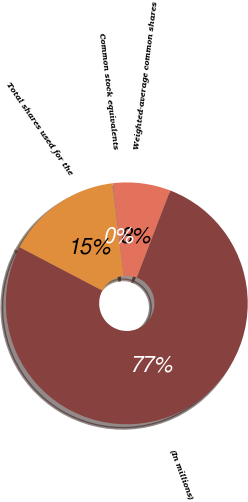<chart> <loc_0><loc_0><loc_500><loc_500><pie_chart><fcel>(In millions)<fcel>Weighted-average common shares<fcel>Common stock equivalents<fcel>Total shares used for the<nl><fcel>76.84%<fcel>7.72%<fcel>0.04%<fcel>15.4%<nl></chart> 